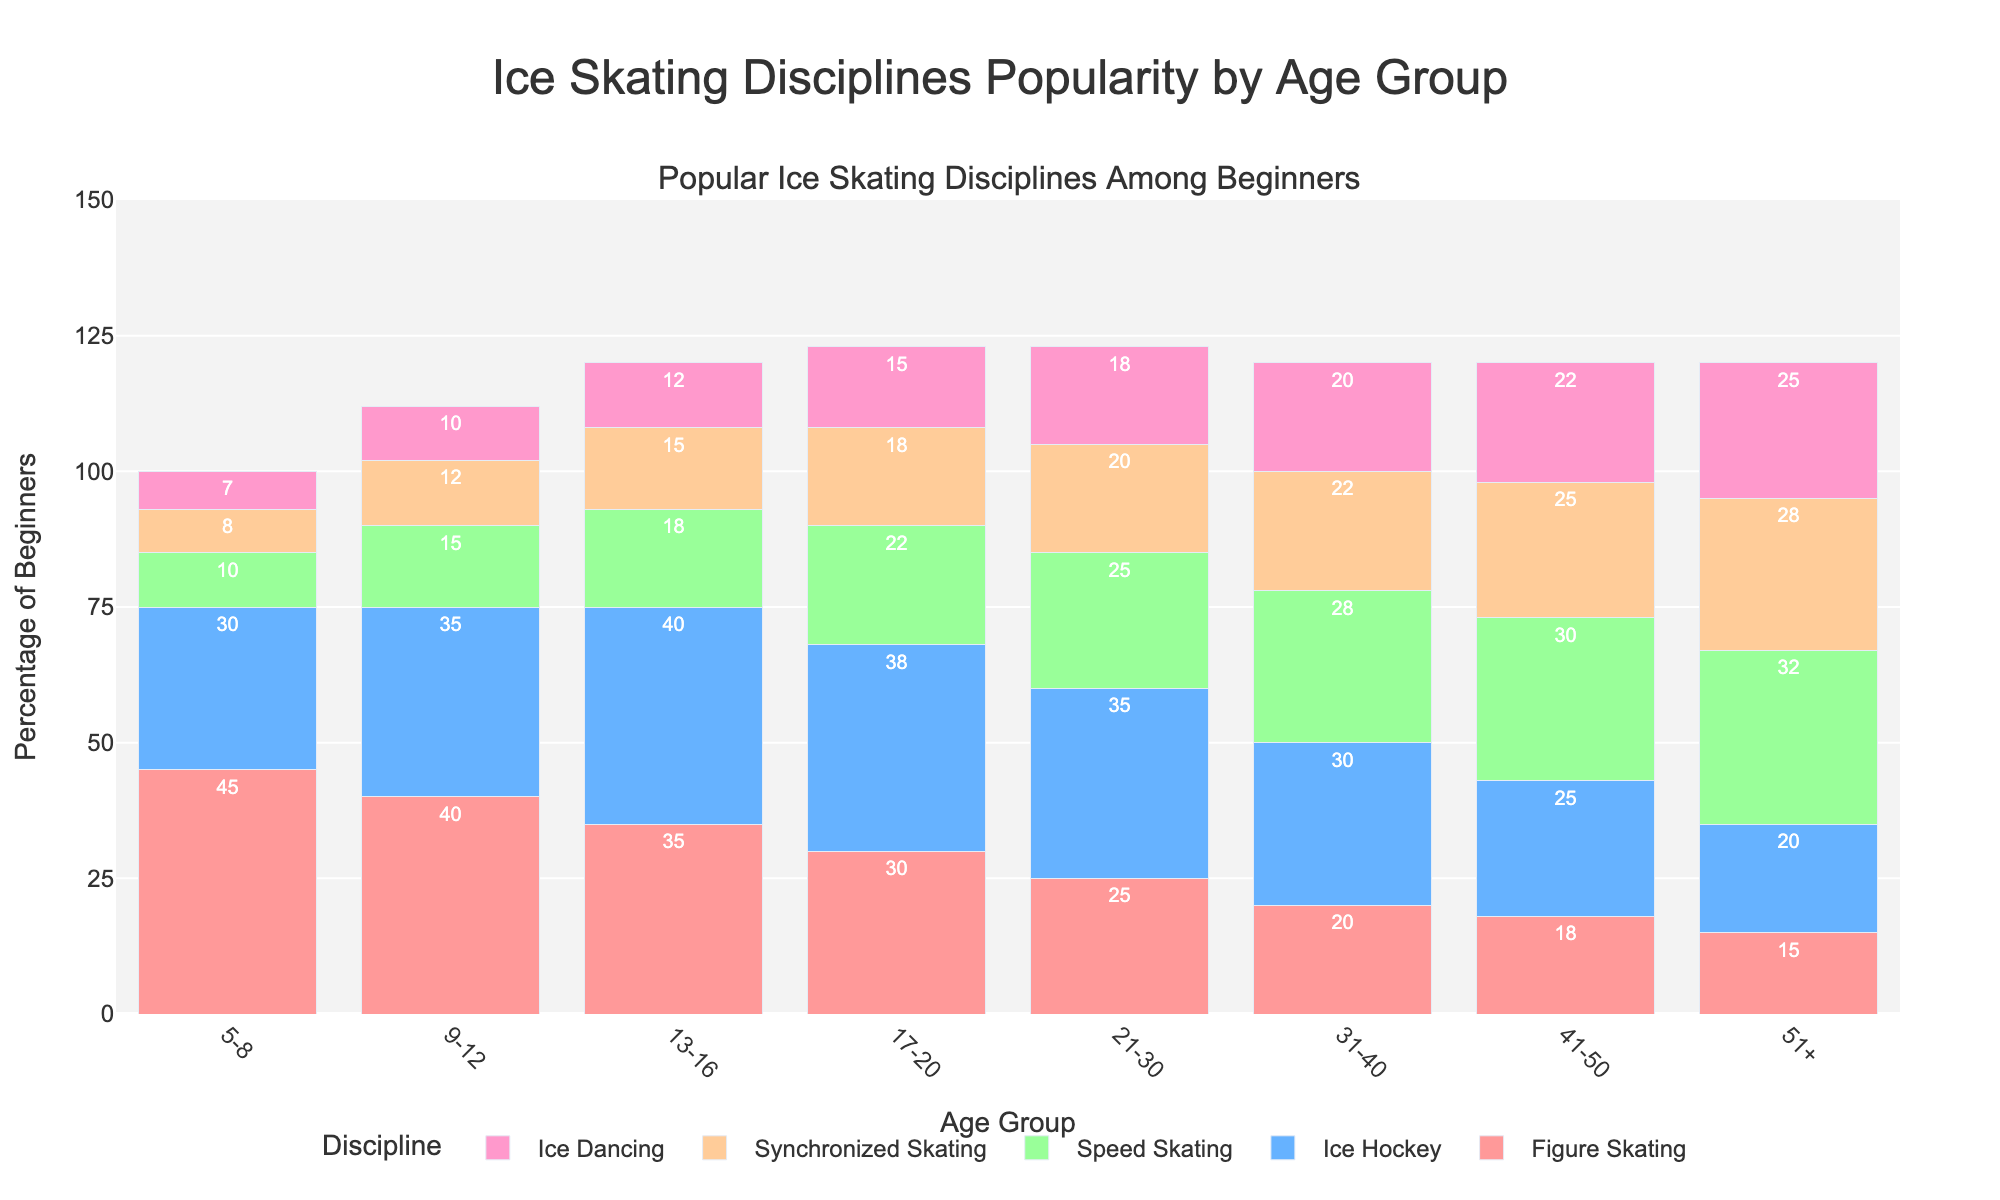What is the most popular ice skating discipline among beginners aged 5-8? In the figure, find the bar segment corresponding to the 5-8 age group for each discipline. The tallest bar segment in this age group represents the most popular discipline.
Answer: Figure Skating How does the popularity of Figure Skating compare between the 13-16 and 31-40 age groups? Refer to the height of the Figure Skating bar segments for the 13-16 and 31-40 age groups. Figure Skating shows 35% for 13-16 and 20% for 31-40.
Answer: Higher in 13-16 Which age group has the highest percentage of beginners in Speed Skating? Look at the Speed Skating bar segments across all age groups. The highest bar segment corresponds to the age group with the highest percentage.
Answer: 51+ What is the total percentage of Ice Hockey beginners in the 21-30 and 31-40 age groups? Add the percentages for the Ice Hockey segments in the 21-30 and 31-40 age groups (35% + 30%).
Answer: 65% Compare the percentage of Ice Dancing beginners in the 51+ age group to the 5-8 age group. Observe the heights of the Ice Dancing segments for the two age groups mentioned. Ice Dancing shows 25% for 51+ and 7% for 5-8.
Answer: Higher in 51+ Which discipline appears to be the most consistently popular across all age groups? By looking at all the bar segments across each discipline, identify the one that has relatively uniform heights across all age groups.
Answer: Ice Hockey Which age group has the lowest percentage of beginners in Synchronized Skating? Identify the shortest bar segment for Synchronized Skating across all age groups in the figure.
Answer: 5-8 What is the increase in popularity of Speed Skating from the 5-8 to the 51+ age group? Subtract the percentage of Speed Skating beginners in the 5-8 age group from the percentage in the 51+ age group (32% - 10%).
Answer: 22% How does the popularity of Synchronized Skating in the 41-50 age group compare to Ice Dancing in the same age group? Compare the heights of the Synchronized Skating and Ice Dancing bar segments within the 41-50 age group. Synchronized Skating is 25% and Ice Dancing is 22%.
Answer: Slightly higher 